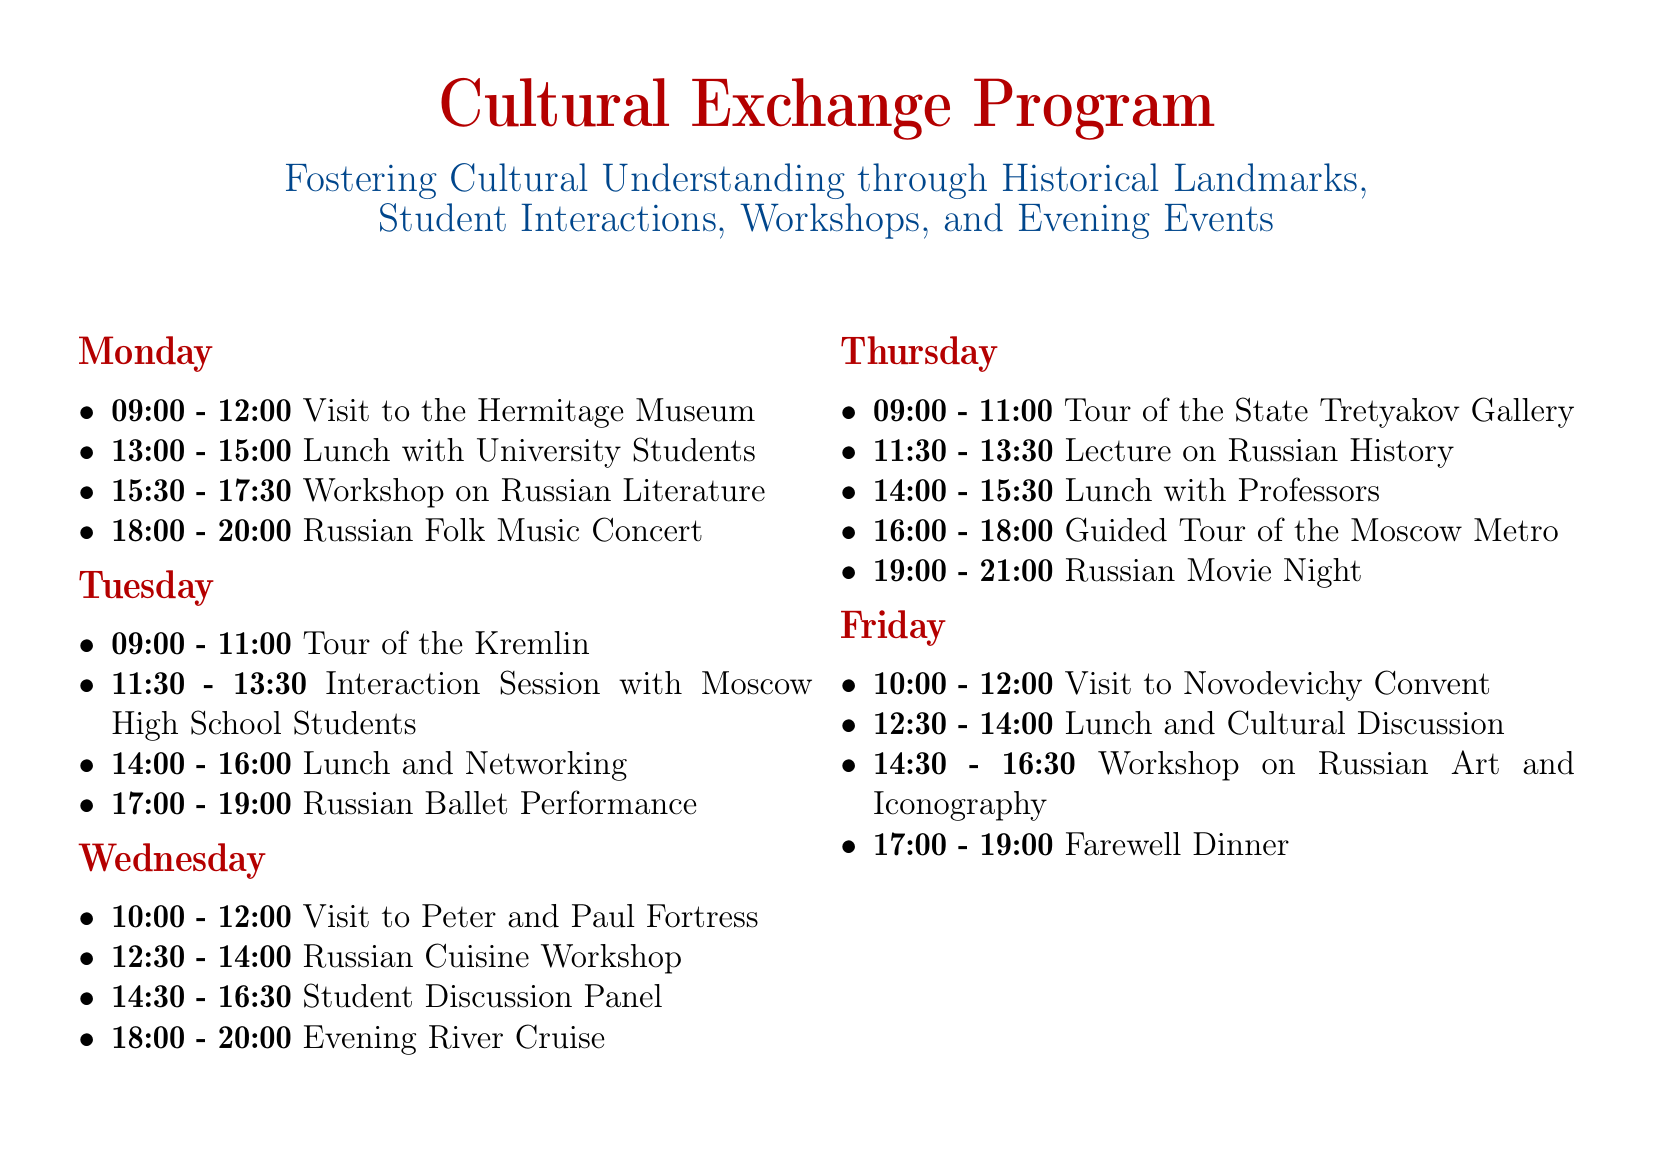what activity is scheduled for Monday afternoon? The activity scheduled for Monday afternoon is a Workshop on Russian Literature from 15:30 to 17:30.
Answer: Workshop on Russian Literature what time does the Russian Ballet Performance start? The Russian Ballet Performance starts at 17:00 on Tuesday.
Answer: 17:00 which historical site is visited on Friday? The historical site visited on Friday is Novodevichy Convent.
Answer: Novodevichy Convent how many workshops are planned during the week? There are three workshops planned: one on Russian Literature, one on Russian Cuisine, and one on Russian Art and Iconography, making a total of three.
Answer: three what is the total duration of student interaction sessions in the program? There are two student interaction sessions: one with Moscow High School students on Tuesday and one discussion panel on Wednesday, resulting in a total duration of 4 hours (2 hours + 2 hours).
Answer: 4 hours what evening event is scheduled after lunch on Thursday? The evening event scheduled after lunch on Thursday is the Russian Movie Night at 19:00.
Answer: Russian Movie Night which city's metro system will be toured? The metro system that will be toured is in Moscow.
Answer: Moscow what is the focus of the visits during the program? The focus of the visits during the program is world-renowned museums and historical sites.
Answer: world-renowned museums and historical sites 